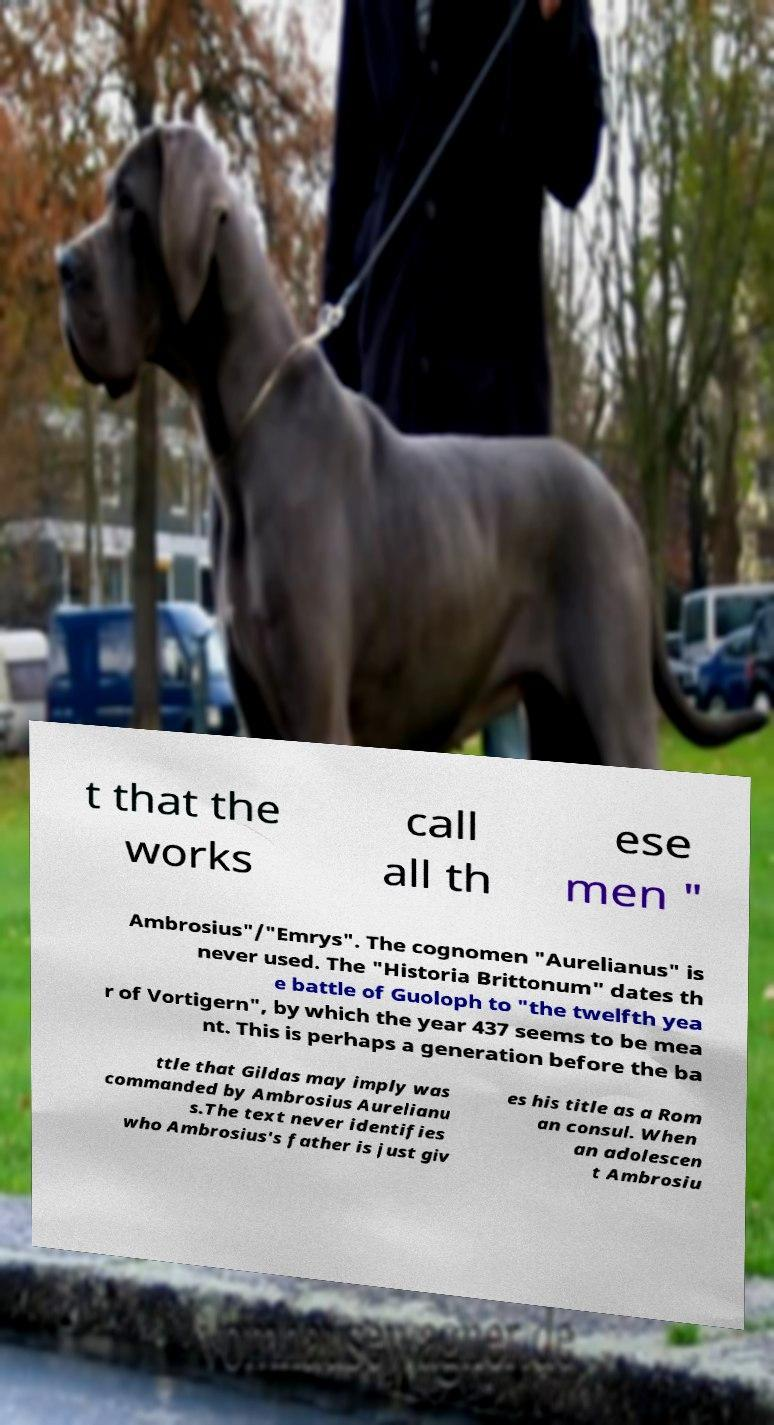Could you assist in decoding the text presented in this image and type it out clearly? t that the works call all th ese men " Ambrosius"/"Emrys". The cognomen "Aurelianus" is never used. The "Historia Brittonum" dates th e battle of Guoloph to "the twelfth yea r of Vortigern", by which the year 437 seems to be mea nt. This is perhaps a generation before the ba ttle that Gildas may imply was commanded by Ambrosius Aurelianu s.The text never identifies who Ambrosius's father is just giv es his title as a Rom an consul. When an adolescen t Ambrosiu 